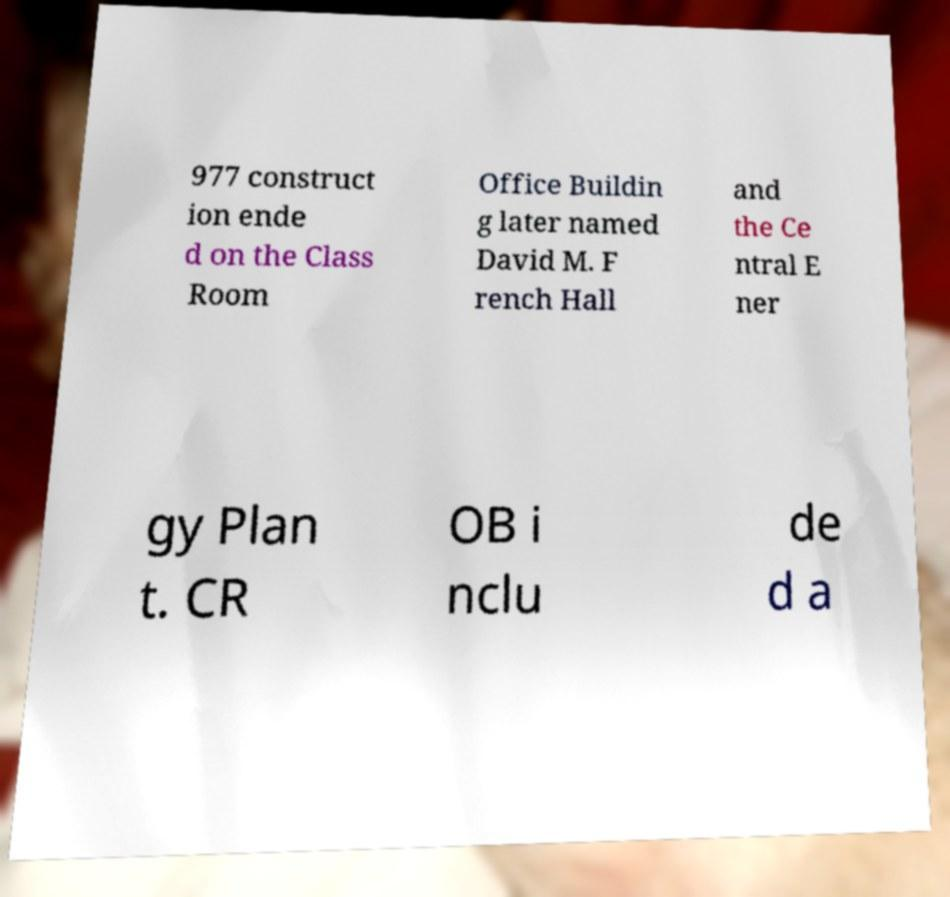Please read and relay the text visible in this image. What does it say? 977 construct ion ende d on the Class Room Office Buildin g later named David M. F rench Hall and the Ce ntral E ner gy Plan t. CR OB i nclu de d a 